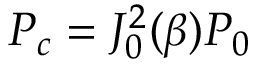Convert formula to latex. <formula><loc_0><loc_0><loc_500><loc_500>P _ { c } = J _ { 0 } ^ { 2 } ( \beta ) P _ { 0 }</formula> 